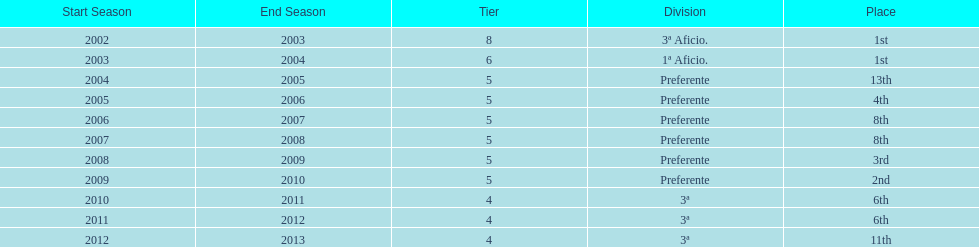Which division placed more than aficio 1a and 3a? Preferente. 